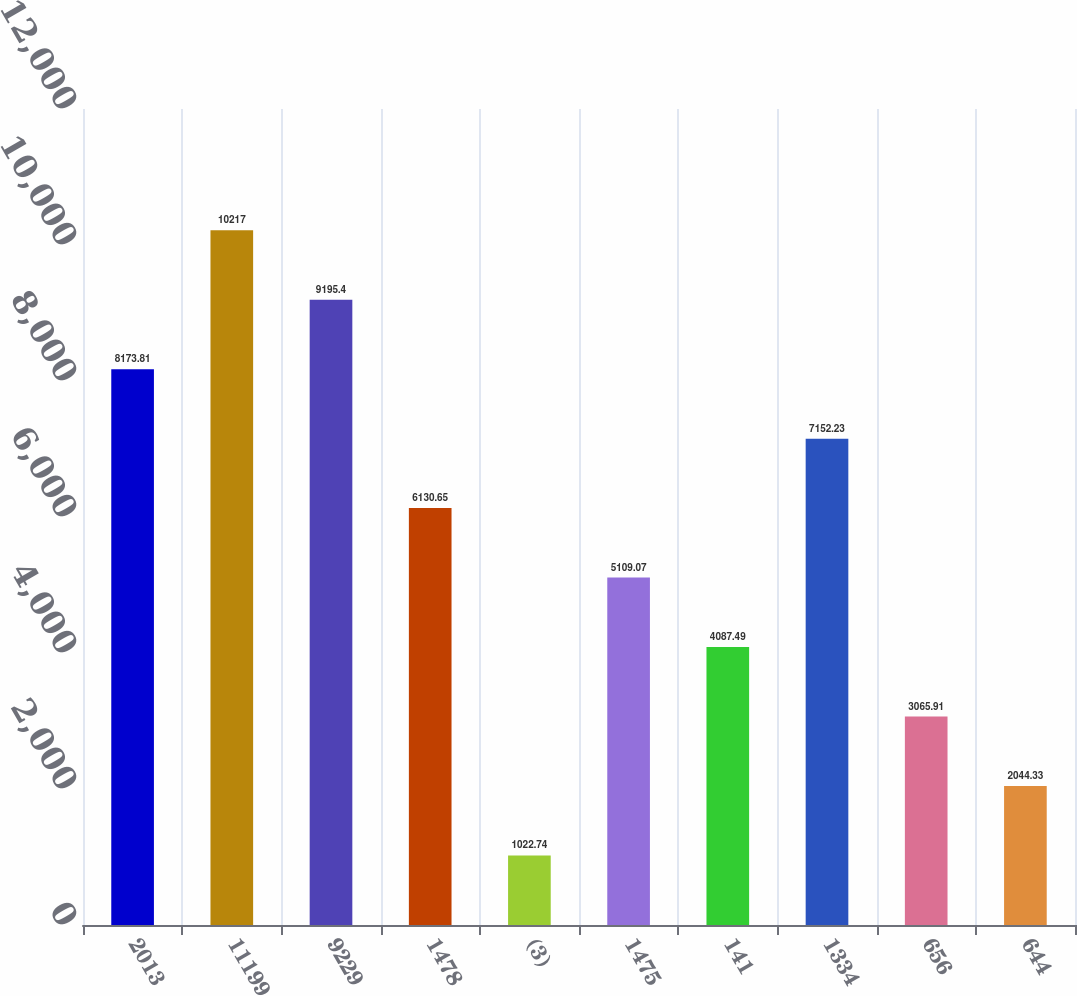<chart> <loc_0><loc_0><loc_500><loc_500><bar_chart><fcel>2013<fcel>11199<fcel>9229<fcel>1478<fcel>(3)<fcel>1475<fcel>141<fcel>1334<fcel>656<fcel>644<nl><fcel>8173.81<fcel>10217<fcel>9195.4<fcel>6130.65<fcel>1022.74<fcel>5109.07<fcel>4087.49<fcel>7152.23<fcel>3065.91<fcel>2044.33<nl></chart> 